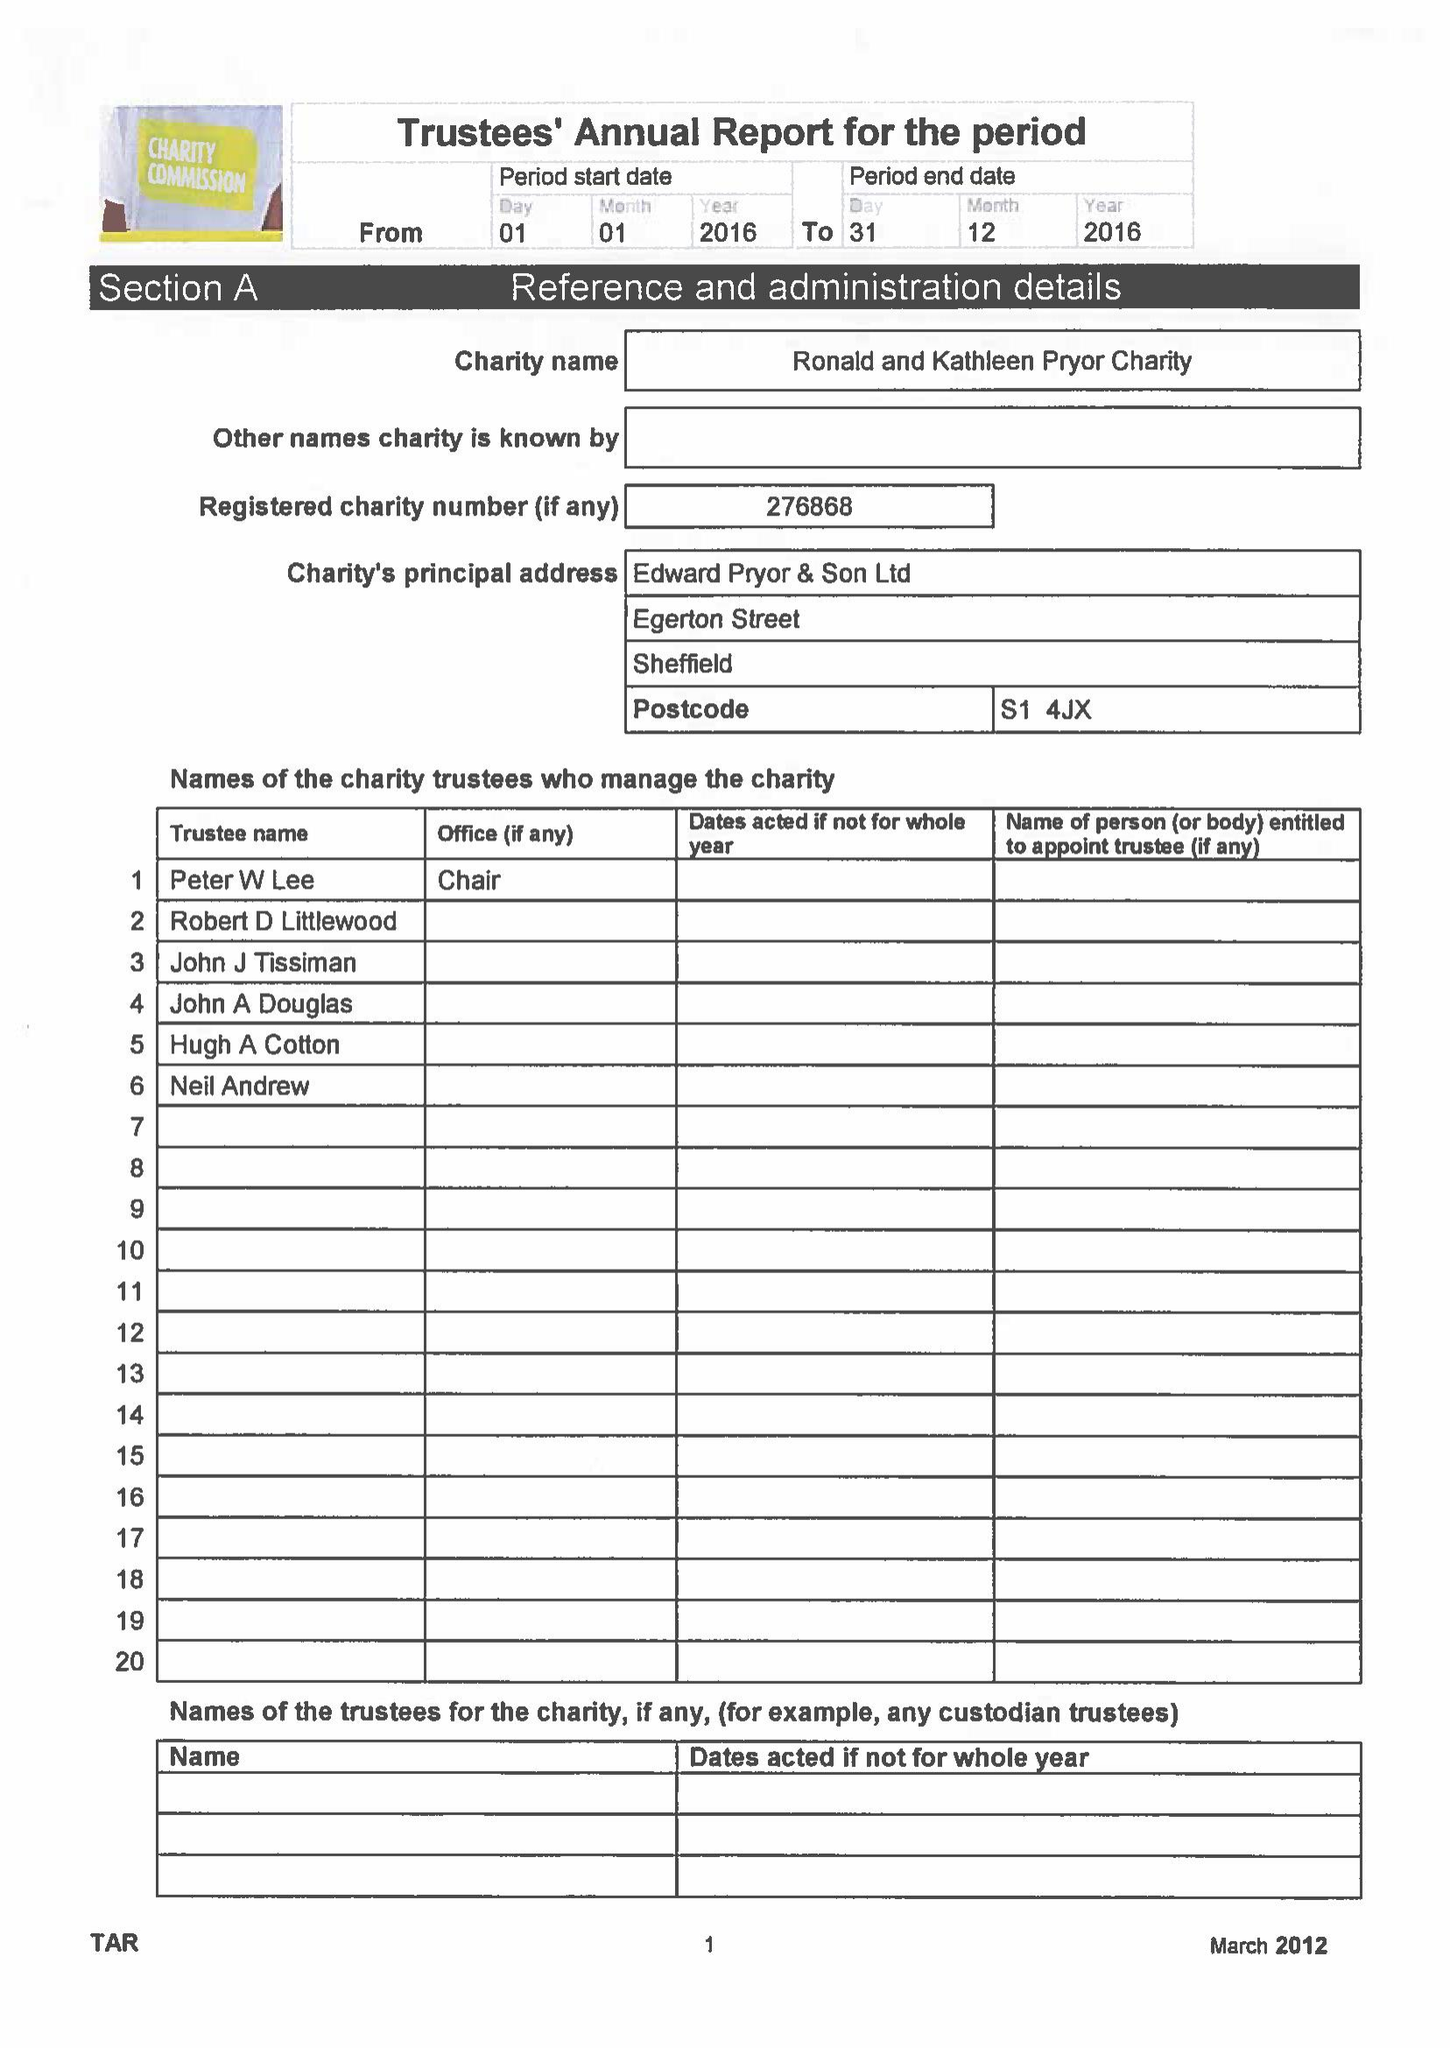What is the value for the report_date?
Answer the question using a single word or phrase. 2016-12-31 